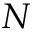Convert formula to latex. <formula><loc_0><loc_0><loc_500><loc_500>N</formula> 